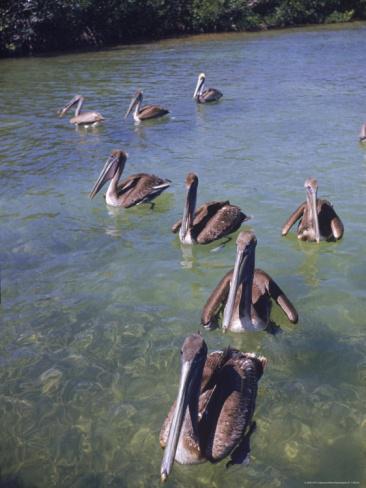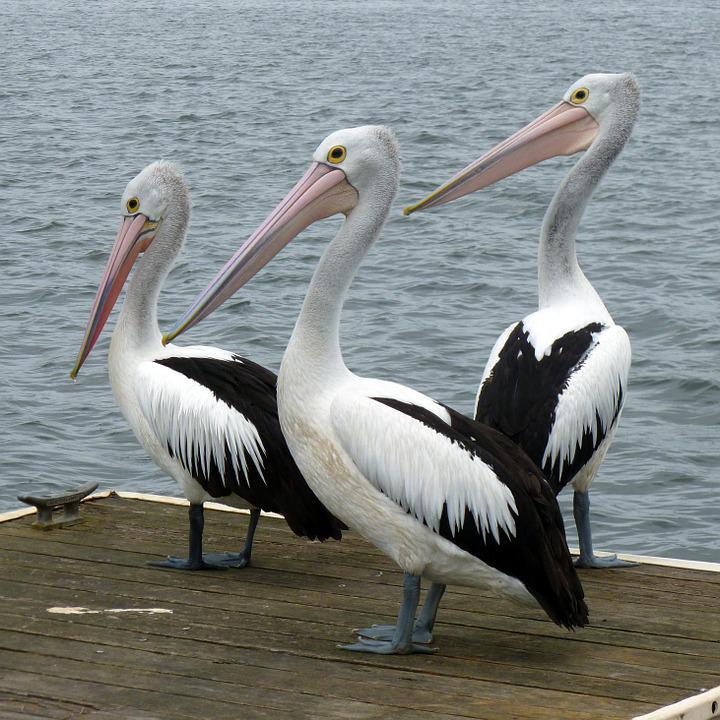The first image is the image on the left, the second image is the image on the right. Given the left and right images, does the statement "One of the images contains a single bird only." hold true? Answer yes or no. No. The first image is the image on the left, the second image is the image on the right. Considering the images on both sides, is "There are at least three birds standing on a dock." valid? Answer yes or no. Yes. 